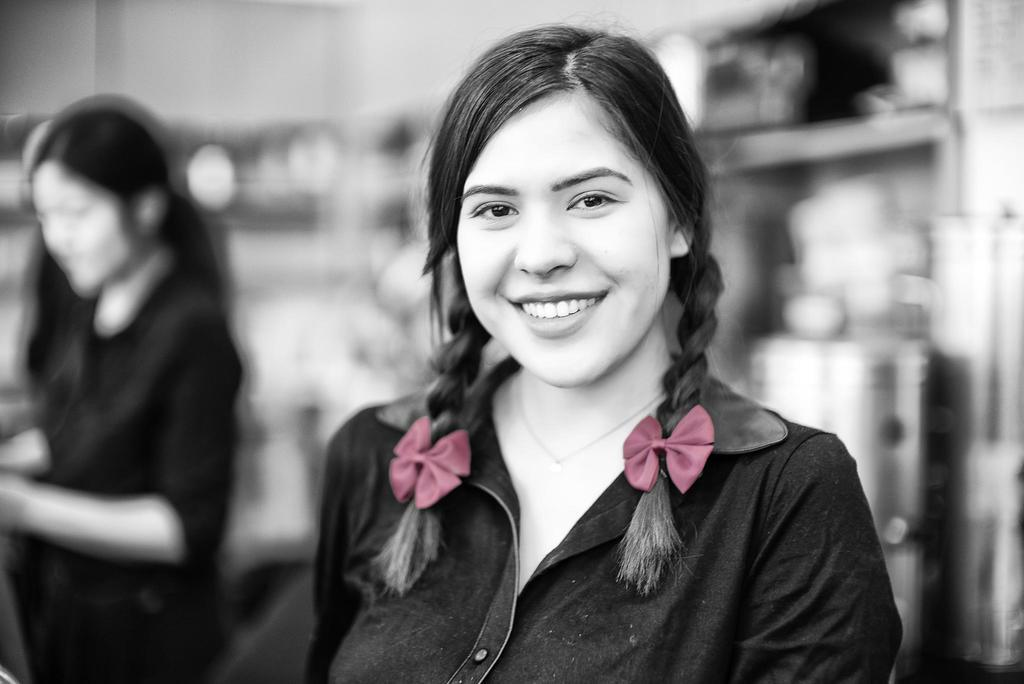Who is the main subject in the foreground of the image? There is a woman in the foreground of the image. What is the woman in the foreground doing? The woman in the foreground is smiling. How would you describe the background of the image? The background of the image is blurry. Are there any other people visible in the image? Yes, there is another woman visible on the left side of the image. What type of throat medicine is the woman in the foreground taking in the image? There is no indication in the image that the woman is taking any throat medicine, and therefore it cannot be determined from the picture. 